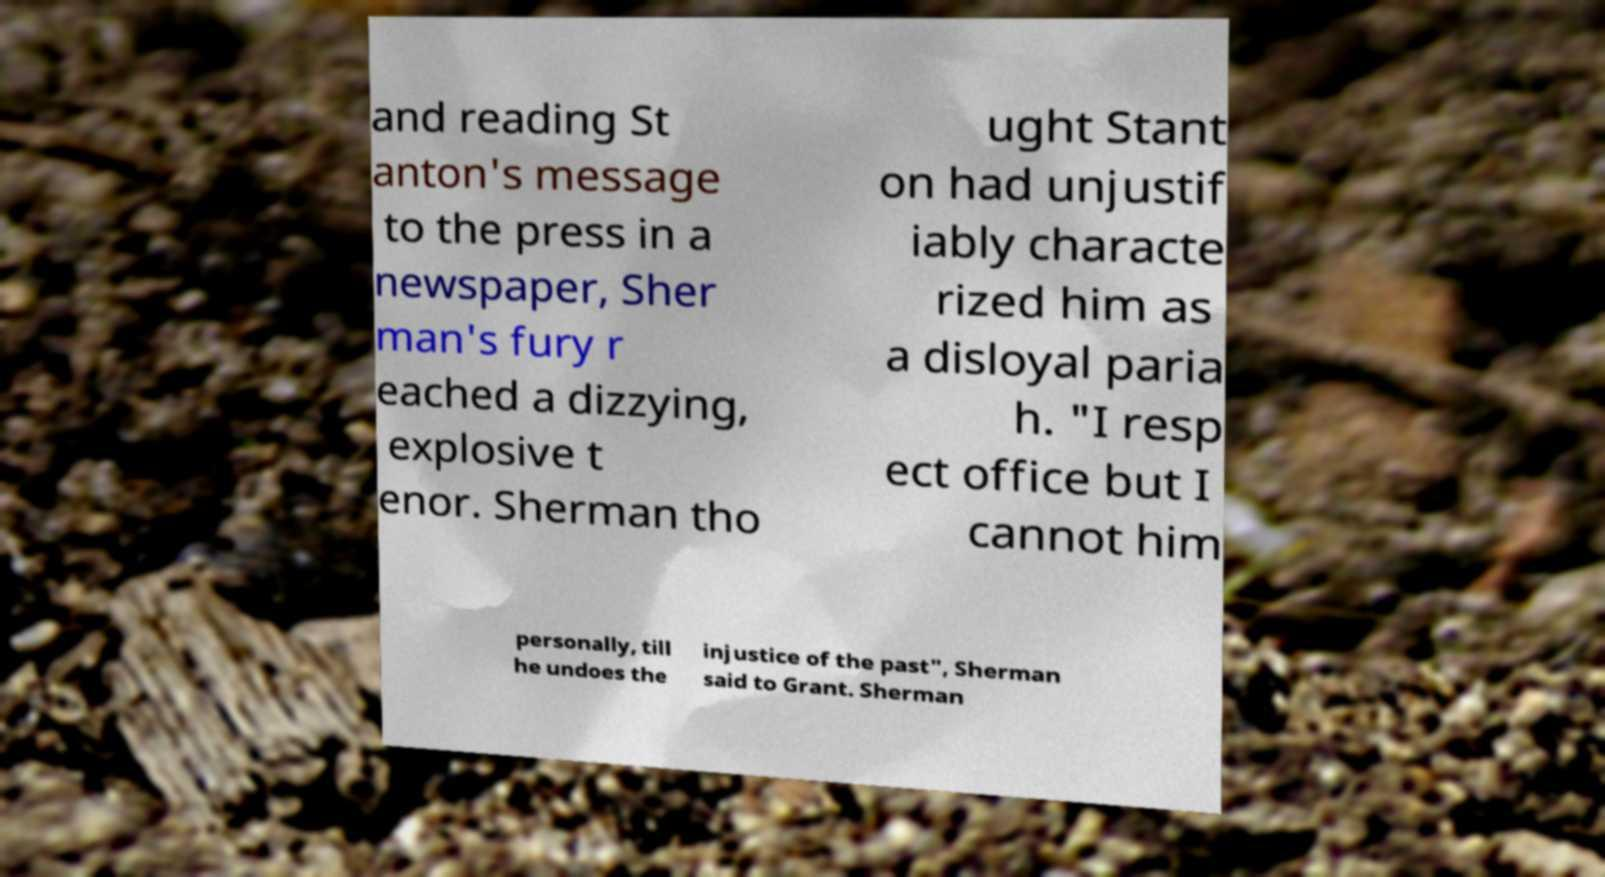What messages or text are displayed in this image? I need them in a readable, typed format. and reading St anton's message to the press in a newspaper, Sher man's fury r eached a dizzying, explosive t enor. Sherman tho ught Stant on had unjustif iably characte rized him as a disloyal paria h. "I resp ect office but I cannot him personally, till he undoes the injustice of the past", Sherman said to Grant. Sherman 